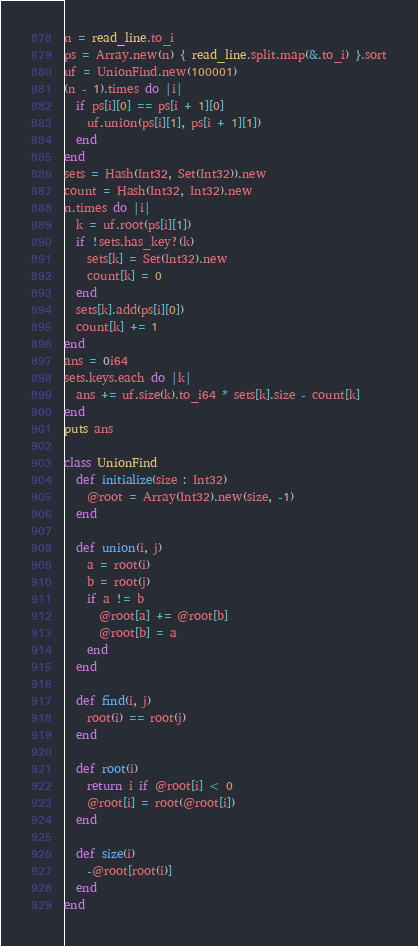Convert code to text. <code><loc_0><loc_0><loc_500><loc_500><_Crystal_>n = read_line.to_i
ps = Array.new(n) { read_line.split.map(&.to_i) }.sort
uf = UnionFind.new(100001)
(n - 1).times do |i|
  if ps[i][0] == ps[i + 1][0]
    uf.union(ps[i][1], ps[i + 1][1])
  end
end
sets = Hash(Int32, Set(Int32)).new
count = Hash(Int32, Int32).new
n.times do |i|
  k = uf.root(ps[i][1])
  if !sets.has_key?(k)
    sets[k] = Set(Int32).new
    count[k] = 0
  end
  sets[k].add(ps[i][0])
  count[k] += 1
end
ans = 0i64
sets.keys.each do |k|
  ans += uf.size(k).to_i64 * sets[k].size - count[k]
end
puts ans

class UnionFind
  def initialize(size : Int32)
    @root = Array(Int32).new(size, -1)
  end

  def union(i, j)
    a = root(i)
    b = root(j)
    if a != b
      @root[a] += @root[b]
      @root[b] = a
    end
  end

  def find(i, j)
    root(i) == root(j)
  end

  def root(i)
    return i if @root[i] < 0
    @root[i] = root(@root[i])
  end

  def size(i)
    -@root[root(i)]
  end
end
</code> 